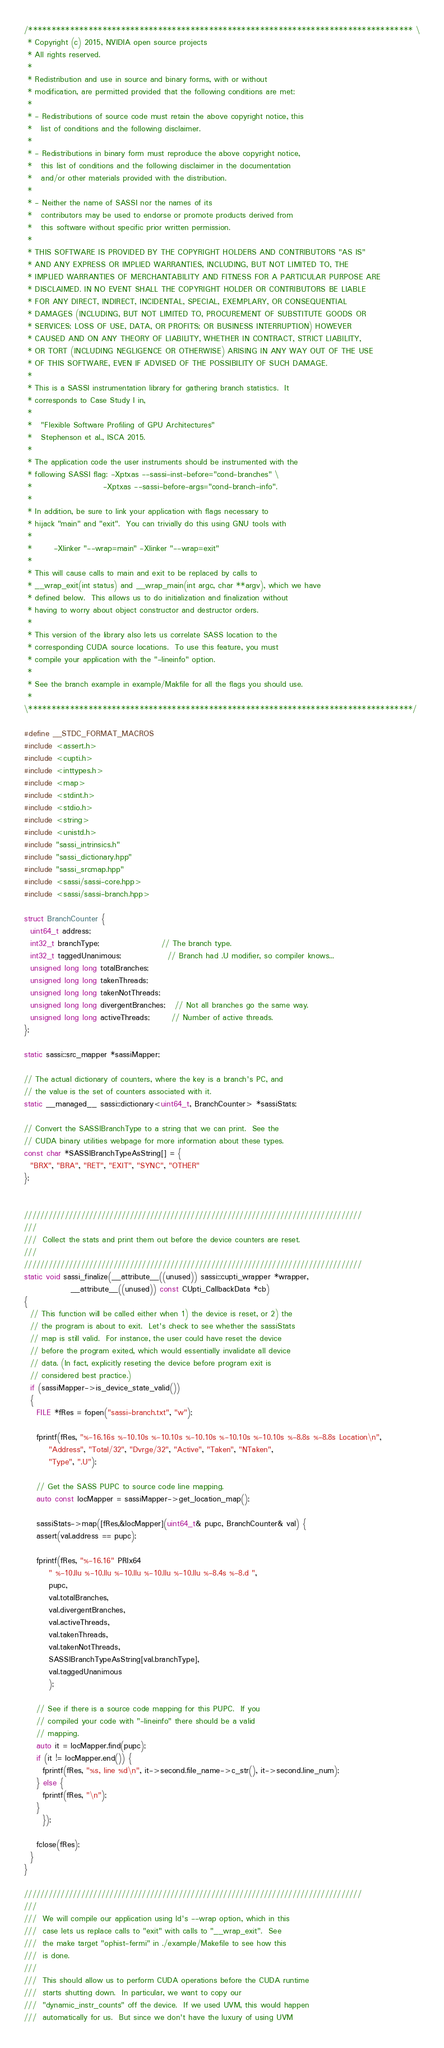Convert code to text. <code><loc_0><loc_0><loc_500><loc_500><_Cuda_>/*********************************************************************************** \
 * Copyright (c) 2015, NVIDIA open source projects
 * All rights reserved.
 * 
 * Redistribution and use in source and binary forms, with or without
 * modification, are permitted provided that the following conditions are met:
 * 
 * - Redistributions of source code must retain the above copyright notice, this
 *   list of conditions and the following disclaimer.
 * 
 * - Redistributions in binary form must reproduce the above copyright notice,
 *   this list of conditions and the following disclaimer in the documentation
 *   and/or other materials provided with the distribution.
 * 
 * - Neither the name of SASSI nor the names of its
 *   contributors may be used to endorse or promote products derived from
 *   this software without specific prior written permission.
 * 
 * THIS SOFTWARE IS PROVIDED BY THE COPYRIGHT HOLDERS AND CONTRIBUTORS "AS IS"
 * AND ANY EXPRESS OR IMPLIED WARRANTIES, INCLUDING, BUT NOT LIMITED TO, THE
 * IMPLIED WARRANTIES OF MERCHANTABILITY AND FITNESS FOR A PARTICULAR PURPOSE ARE
 * DISCLAIMED. IN NO EVENT SHALL THE COPYRIGHT HOLDER OR CONTRIBUTORS BE LIABLE
 * FOR ANY DIRECT, INDIRECT, INCIDENTAL, SPECIAL, EXEMPLARY, OR CONSEQUENTIAL
 * DAMAGES (INCLUDING, BUT NOT LIMITED TO, PROCUREMENT OF SUBSTITUTE GOODS OR
 * SERVICES; LOSS OF USE, DATA, OR PROFITS; OR BUSINESS INTERRUPTION) HOWEVER
 * CAUSED AND ON ANY THEORY OF LIABILITY, WHETHER IN CONTRACT, STRICT LIABILITY,
 * OR TORT (INCLUDING NEGLIGENCE OR OTHERWISE) ARISING IN ANY WAY OUT OF THE USE
 * OF THIS SOFTWARE, EVEN IF ADVISED OF THE POSSIBILITY OF SUCH DAMAGE.
 *
 * This is a SASSI instrumentation library for gathering branch statistics.  It 
 * corresponds to Case Study I in,
 *
 *   "Flexible Software Profiling of GPU Architectures"
 *   Stephenson et al., ISCA 2015.
 *  
 * The application code the user instruments should be instrumented with the
 * following SASSI flag: -Xptxas --sassi-inst-before="cond-branches" \
 *                       -Xptxas --sassi-before-args="cond-branch-info".
 *
 * In addition, be sure to link your application with flags necessary to 
 * hijack "main" and "exit".  You can trivially do this using GNU tools with
 *
 *       -Xlinker "--wrap=main" -Xlinker "--wrap=exit"
 *
 * This will cause calls to main and exit to be replaced by calls to 
 * __wrap_exit(int status) and __wrap_main(int argc, char **argv), which we have
 * defined below.  This allows us to do initialization and finalization without
 * having to worry about object constructor and destructor orders.
 *
 * This version of the library also lets us correlate SASS location to the
 * corresponding CUDA source locations.  To use this feature, you must 
 * compile your application with the "-lineinfo" option.
 *
 * See the branch example in example/Makfile for all the flags you should use.
 *
\***********************************************************************************/

#define __STDC_FORMAT_MACROS
#include <assert.h>
#include <cupti.h>
#include <inttypes.h>
#include <map>
#include <stdint.h>
#include <stdio.h>
#include <string>
#include <unistd.h>
#include "sassi_intrinsics.h"
#include "sassi_dictionary.hpp"
#include "sassi_srcmap.hpp"
#include <sassi/sassi-core.hpp>
#include <sassi/sassi-branch.hpp>

struct BranchCounter {
  uint64_t address;
  int32_t branchType;                    // The branch type.
  int32_t taggedUnanimous;               // Branch had .U modifier, so compiler knows...
  unsigned long long totalBranches;
  unsigned long long takenThreads;
  unsigned long long takenNotThreads;
  unsigned long long divergentBranches;   // Not all branches go the same way.
  unsigned long long activeThreads;       // Number of active threads.
};                                        

static sassi::src_mapper *sassiMapper;

// The actual dictionary of counters, where the key is a branch's PC, and
// the value is the set of counters associated with it.
static __managed__ sassi::dictionary<uint64_t, BranchCounter> *sassiStats;

// Convert the SASSIBranchType to a string that we can print.  See the
// CUDA binary utilities webpage for more information about these types.
const char *SASSIBranchTypeAsString[] = {
  "BRX", "BRA", "RET", "EXIT", "SYNC", "OTHER"
};


///////////////////////////////////////////////////////////////////////////////////
///
///  Collect the stats and print them out before the device counters are reset.
///
///////////////////////////////////////////////////////////////////////////////////
static void sassi_finalize(__attribute__((unused)) sassi::cupti_wrapper *wrapper, 
			   __attribute__((unused)) const CUpti_CallbackData *cb)
{
  // This function will be called either when 1) the device is reset, or 2) the
  // the program is about to exit.  Let's check to see whether the sassiStats
  // map is still valid.  For instance, the user could have reset the device 
  // before the program exited, which would essentially invalidate all device
  // data. (In fact, explicitly reseting the device before program exit is
  // considered best practice.)
  if (sassiMapper->is_device_state_valid())
  {
    FILE *fRes = fopen("sassi-branch.txt", "w");
    
    fprintf(fRes, "%-16.16s %-10.10s %-10.10s %-10.10s %-10.10s %-10.10s %-8.8s %-8.8s Location\n",
	    "Address", "Total/32", "Dvrge/32", "Active", "Taken", "NTaken", 
	    "Type", ".U");

    // Get the SASS PUPC to source code line mapping.
    auto const locMapper = sassiMapper->get_location_map();
    
    sassiStats->map([fRes,&locMapper](uint64_t& pupc, BranchCounter& val) {
	assert(val.address == pupc);
	
	fprintf(fRes, "%-16.16" PRIx64 
		" %-10.llu %-10.llu %-10.llu %-10.llu %-10.llu %-8.4s %-8.d ",
		pupc,
		val.totalBranches, 
		val.divergentBranches,
		val.activeThreads,
		val.takenThreads,
		val.takenNotThreads,
		SASSIBranchTypeAsString[val.branchType],
		val.taggedUnanimous
		);      

	// See if there is a source code mapping for this PUPC.  If you 
	// compiled your code with "-lineinfo" there should be a valid
	// mapping.
	auto it = locMapper.find(pupc);
	if (it != locMapper.end()) {
	  fprintf(fRes, "%s, line %d\n", it->second.file_name->c_str(), it->second.line_num);
	} else {
	  fprintf(fRes, "\n");
	}
      });
  
    fclose(fRes);
  }
}

///////////////////////////////////////////////////////////////////////////////////
/// 
///  We will compile our application using ld's --wrap option, which in this
///  case lets us replace calls to "exit" with calls to "__wrap_exit".  See
///  the make target "ophist-fermi" in ./example/Makefile to see how this
///  is done.
///
///  This should allow us to perform CUDA operations before the CUDA runtime
///  starts shutting down.  In particular, we want to copy our
///  "dynamic_instr_counts" off the device.  If we used UVM, this would happen
///  automatically for us.  But since we don't have the luxury of using UVM</code> 